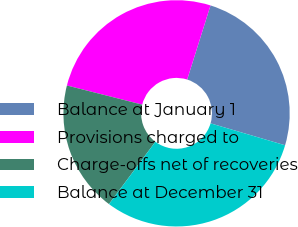Convert chart. <chart><loc_0><loc_0><loc_500><loc_500><pie_chart><fcel>Balance at January 1<fcel>Provisions charged to<fcel>Charge-offs net of recoveries<fcel>Balance at December 31<nl><fcel>24.7%<fcel>25.89%<fcel>18.77%<fcel>30.63%<nl></chart> 